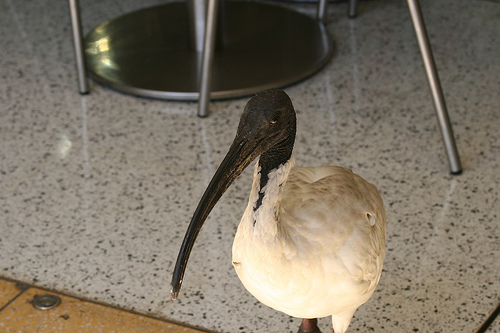Which item of furniture is this? The image shows an ibis, which is a bird, not a piece of furniture. The confusion might arise from the fact that it's indoors and beneath what looks like a stool or chair. 